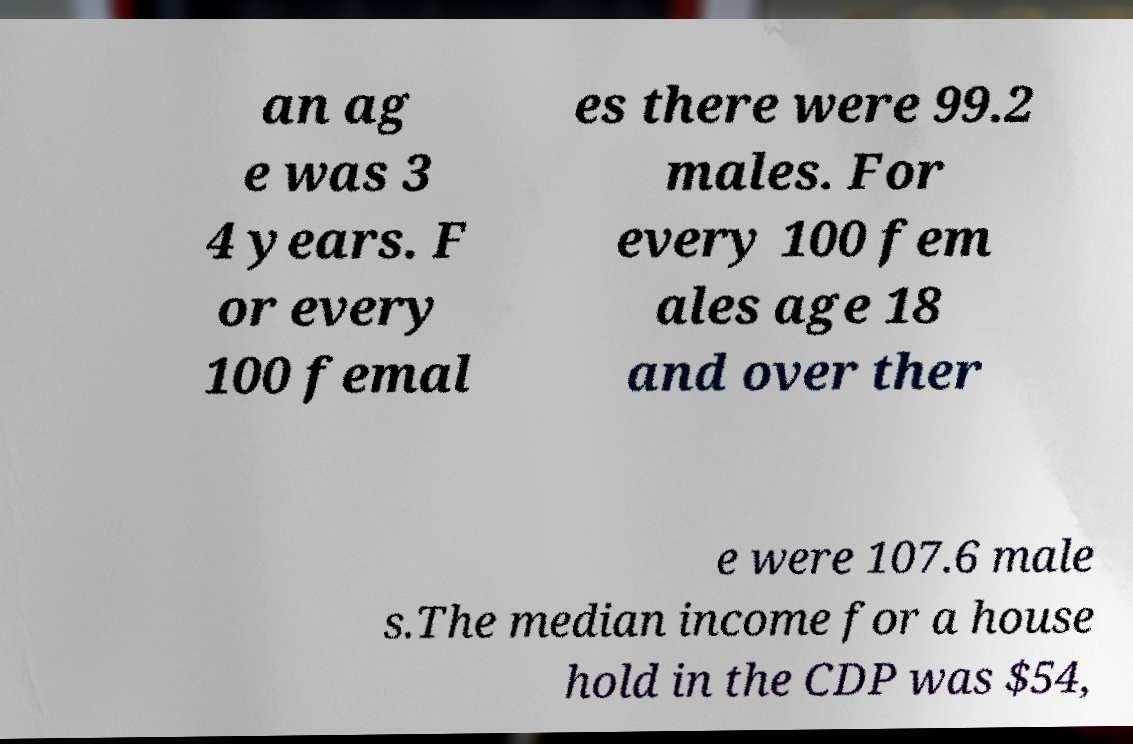Could you assist in decoding the text presented in this image and type it out clearly? an ag e was 3 4 years. F or every 100 femal es there were 99.2 males. For every 100 fem ales age 18 and over ther e were 107.6 male s.The median income for a house hold in the CDP was $54, 